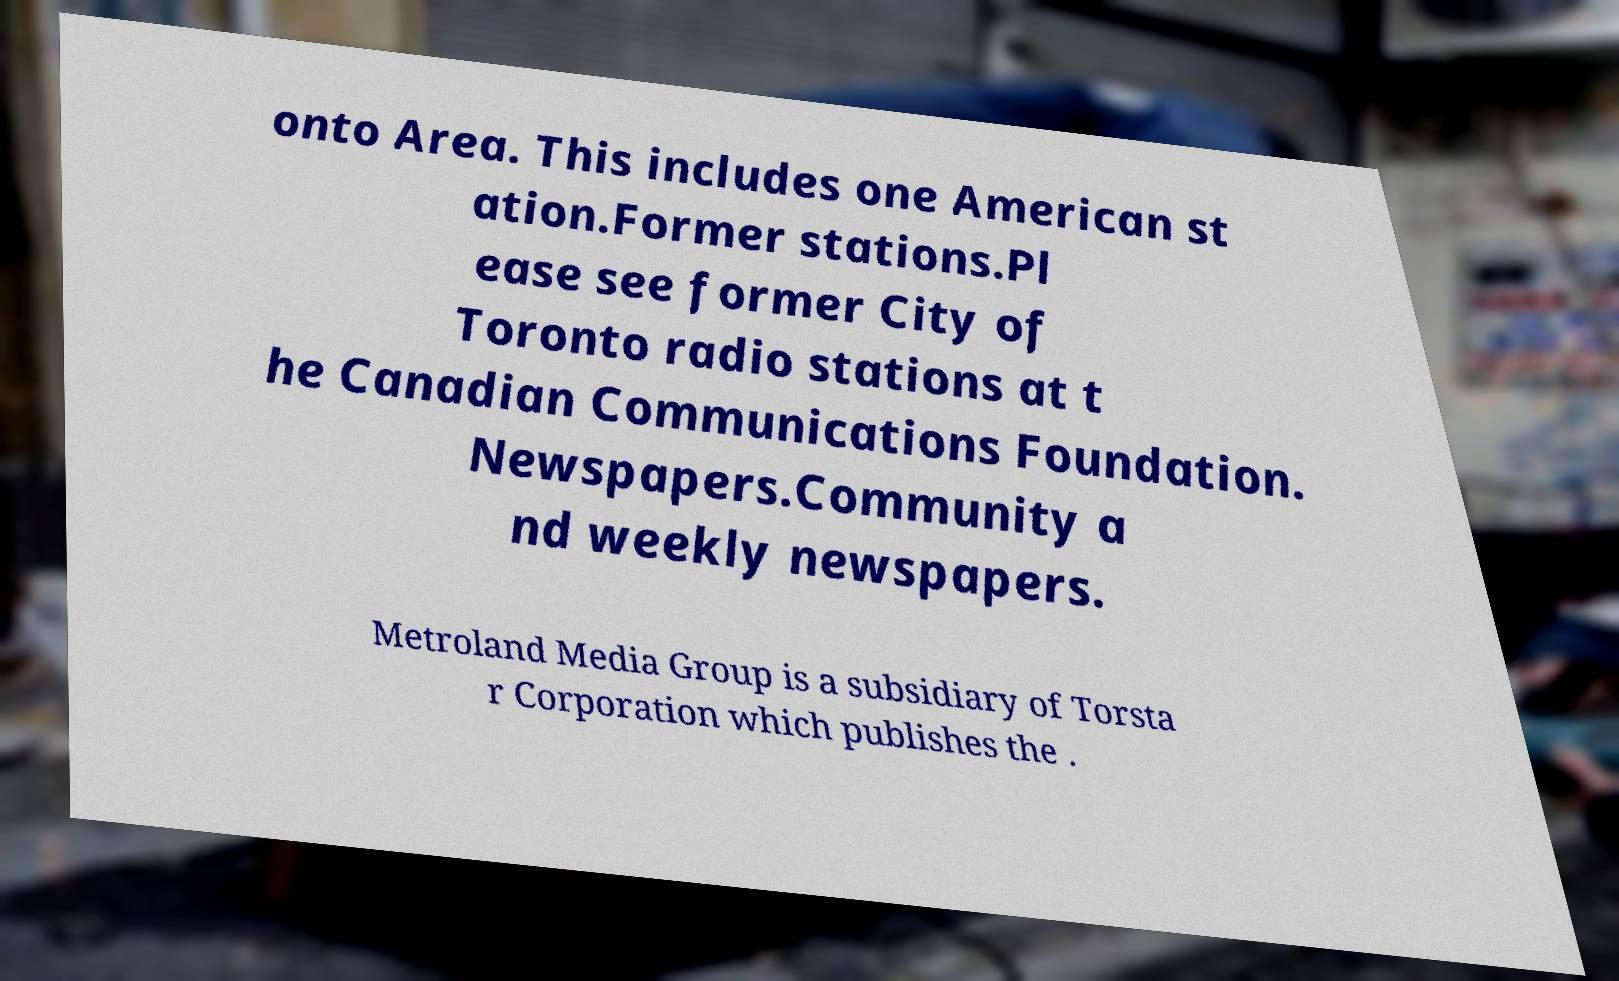What messages or text are displayed in this image? I need them in a readable, typed format. onto Area. This includes one American st ation.Former stations.Pl ease see former City of Toronto radio stations at t he Canadian Communications Foundation. Newspapers.Community a nd weekly newspapers. Metroland Media Group is a subsidiary of Torsta r Corporation which publishes the . 